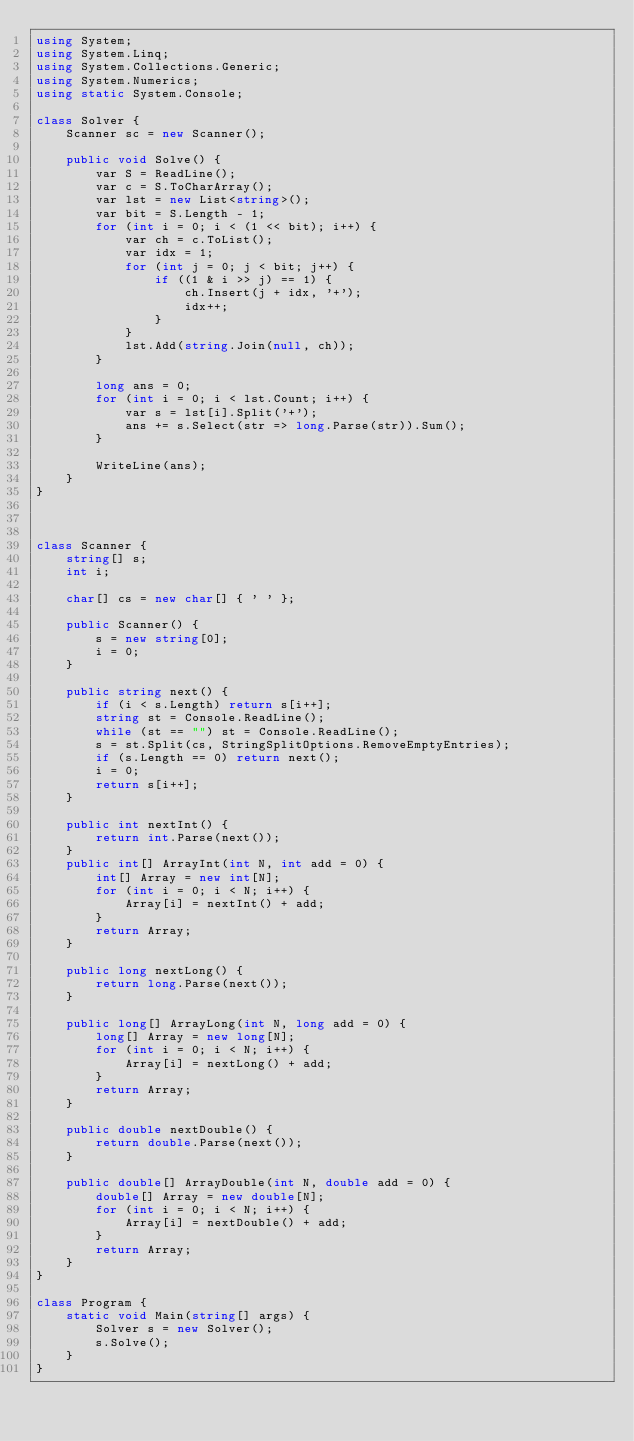Convert code to text. <code><loc_0><loc_0><loc_500><loc_500><_C#_>using System;
using System.Linq;
using System.Collections.Generic;
using System.Numerics;
using static System.Console;

class Solver {
    Scanner sc = new Scanner();

    public void Solve() {
        var S = ReadLine();
        var c = S.ToCharArray();
        var lst = new List<string>();
        var bit = S.Length - 1;
        for (int i = 0; i < (1 << bit); i++) {
            var ch = c.ToList();
            var idx = 1;
            for (int j = 0; j < bit; j++) {
                if ((1 & i >> j) == 1) {
                    ch.Insert(j + idx, '+');
                    idx++;
                }
            }
            lst.Add(string.Join(null, ch));
        }

        long ans = 0;
        for (int i = 0; i < lst.Count; i++) {
            var s = lst[i].Split('+');
            ans += s.Select(str => long.Parse(str)).Sum();
        }

        WriteLine(ans);
    }
}



class Scanner {
    string[] s;
    int i;

    char[] cs = new char[] { ' ' };

    public Scanner() {
        s = new string[0];
        i = 0;
    }

    public string next() {
        if (i < s.Length) return s[i++];
        string st = Console.ReadLine();
        while (st == "") st = Console.ReadLine();
        s = st.Split(cs, StringSplitOptions.RemoveEmptyEntries);
        if (s.Length == 0) return next();
        i = 0;
        return s[i++];
    }

    public int nextInt() {
        return int.Parse(next());
    }
    public int[] ArrayInt(int N, int add = 0) {
        int[] Array = new int[N];
        for (int i = 0; i < N; i++) {
            Array[i] = nextInt() + add;
        }
        return Array;
    }

    public long nextLong() {
        return long.Parse(next());
    }

    public long[] ArrayLong(int N, long add = 0) {
        long[] Array = new long[N];
        for (int i = 0; i < N; i++) {
            Array[i] = nextLong() + add;
        }
        return Array;
    }

    public double nextDouble() {
        return double.Parse(next());
    }

    public double[] ArrayDouble(int N, double add = 0) {
        double[] Array = new double[N];
        for (int i = 0; i < N; i++) {
            Array[i] = nextDouble() + add;
        }
        return Array;
    }
}

class Program {
    static void Main(string[] args) {
        Solver s = new Solver();
        s.Solve();
    }
}</code> 